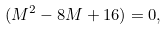Convert formula to latex. <formula><loc_0><loc_0><loc_500><loc_500>( M ^ { 2 } - 8 M + 1 6 ) = 0 ,</formula> 